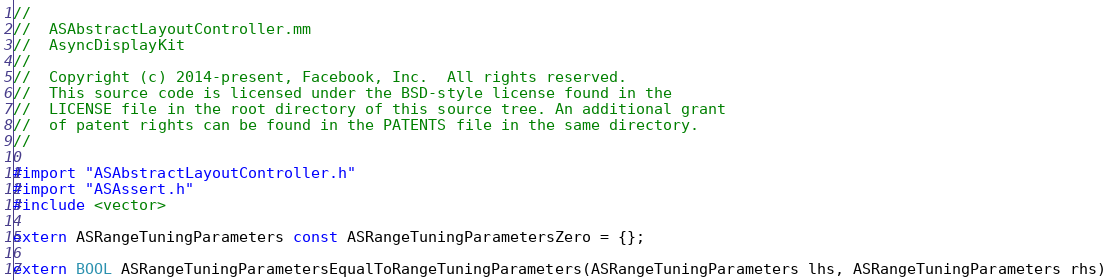Convert code to text. <code><loc_0><loc_0><loc_500><loc_500><_ObjectiveC_>//
//  ASAbstractLayoutController.mm
//  AsyncDisplayKit
//
//  Copyright (c) 2014-present, Facebook, Inc.  All rights reserved.
//  This source code is licensed under the BSD-style license found in the
//  LICENSE file in the root directory of this source tree. An additional grant
//  of patent rights can be found in the PATENTS file in the same directory.
//

#import "ASAbstractLayoutController.h"
#import "ASAssert.h"
#include <vector>

extern ASRangeTuningParameters const ASRangeTuningParametersZero = {};

extern BOOL ASRangeTuningParametersEqualToRangeTuningParameters(ASRangeTuningParameters lhs, ASRangeTuningParameters rhs)</code> 